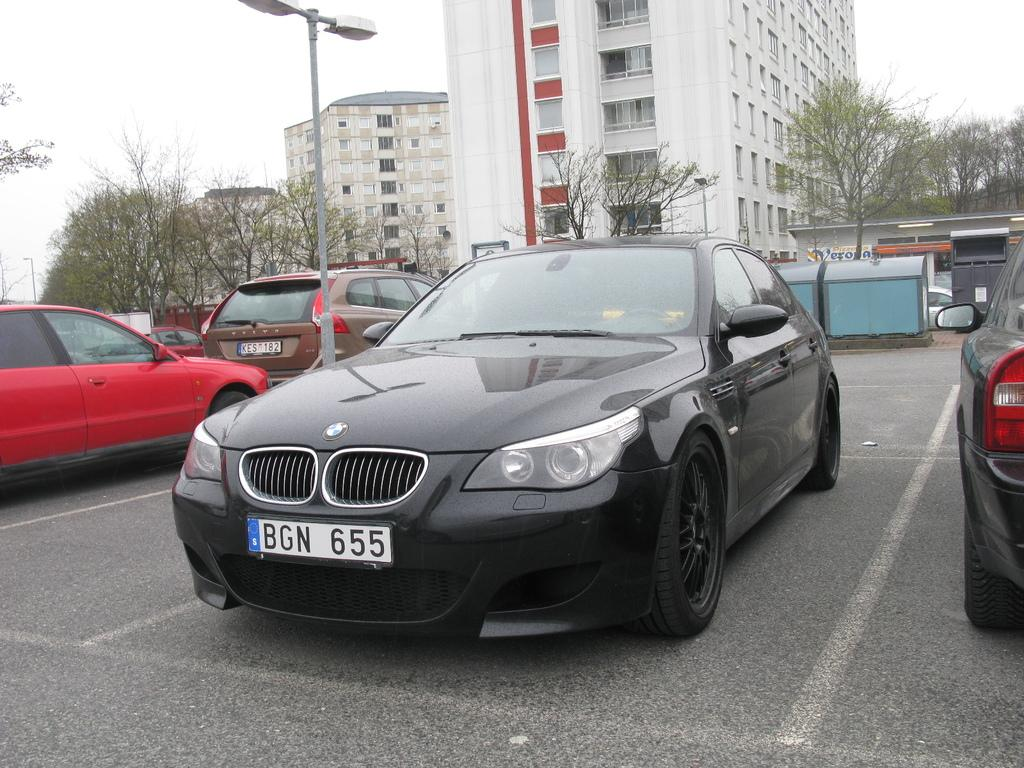What can be seen in the foreground of the image? There are cars parked in the foreground of the image. Where are the cars located? The cars are in a parking space. What is on the left side of the image? There is a light pole on the left side of the image. What can be seen in the background of the image? There are buildings and trees in the background of the image. What type of amusement park can be seen in the background of the image? There is no amusement park visible in the background of the image; it features buildings and trees. How many fingers are visible on the cars in the image? Cars do not have fingers, so this question cannot be answered. 